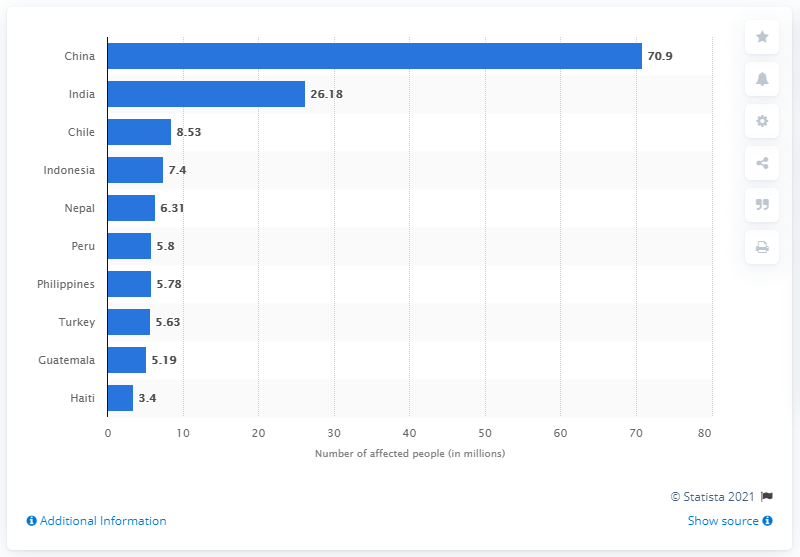How many people in China were affected by earthquakes between 1900 and 2016? Between 1900 and 2016, approximately 70.9 million people in China were affected by earthquakes. This significant figure highlights the substantial impact of seismic activities in the region, underscoring the importance of earthquake preparedness and resilience in disaster-prone areas. 